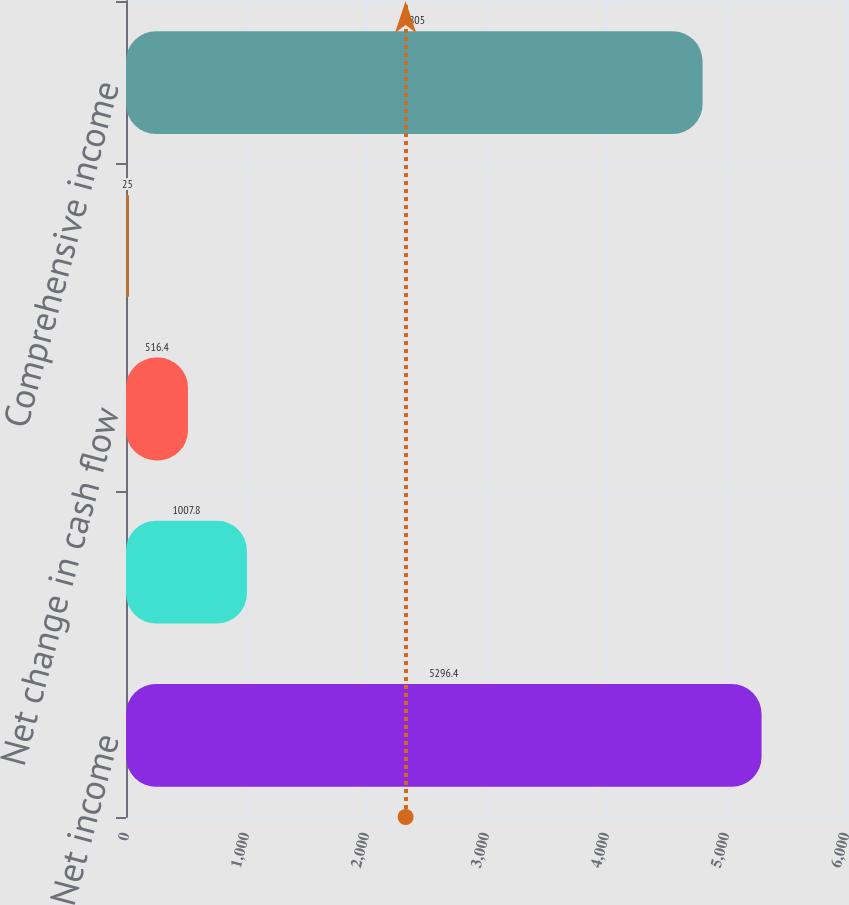Convert chart. <chart><loc_0><loc_0><loc_500><loc_500><bar_chart><fcel>Net income<fcel>Foreign currency translation<fcel>Net change in cash flow<fcel>Minimum pension liability<fcel>Comprehensive income<nl><fcel>5296.4<fcel>1007.8<fcel>516.4<fcel>25<fcel>4805<nl></chart> 